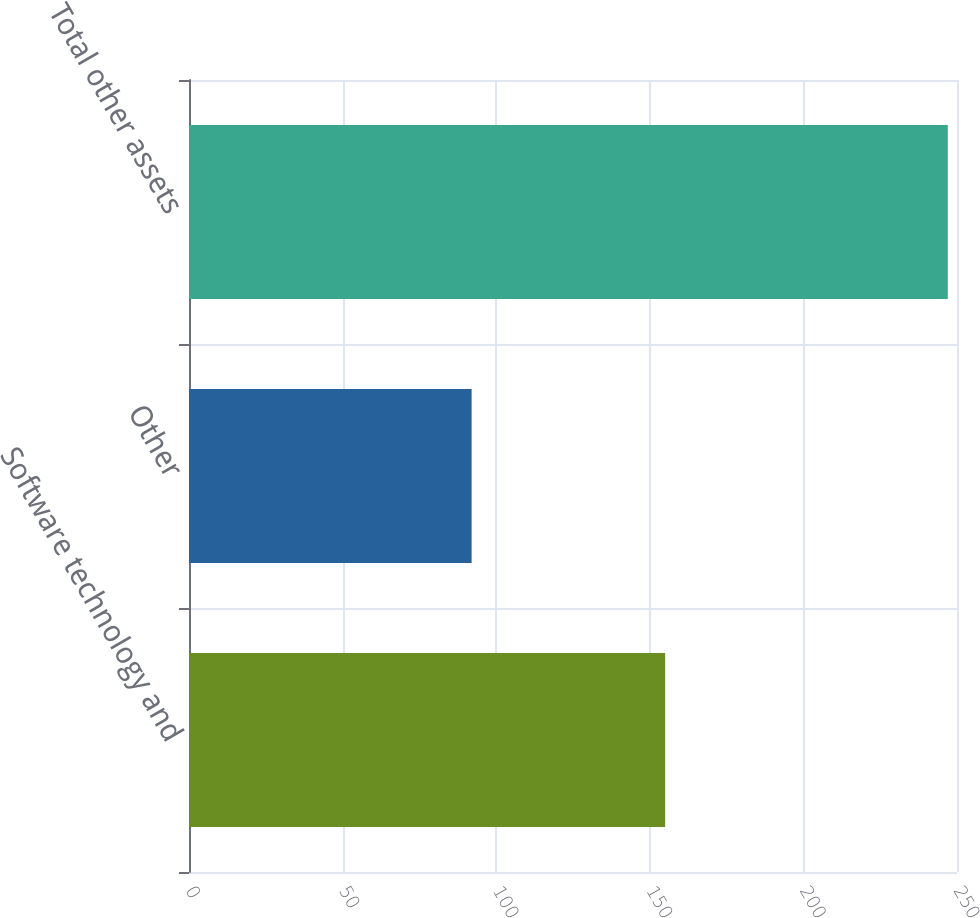Convert chart. <chart><loc_0><loc_0><loc_500><loc_500><bar_chart><fcel>Software technology and<fcel>Other<fcel>Total other assets<nl><fcel>155<fcel>92<fcel>247<nl></chart> 